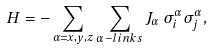<formula> <loc_0><loc_0><loc_500><loc_500>H = - \sum _ { \alpha = x , y , z } \sum _ { \alpha - l i n k s } J _ { \alpha } \, \sigma _ { i } ^ { \alpha } \sigma _ { j } ^ { \alpha } ,</formula> 